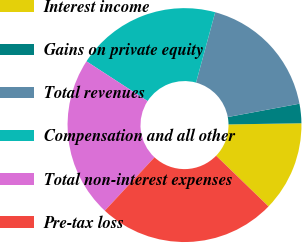Convert chart. <chart><loc_0><loc_0><loc_500><loc_500><pie_chart><fcel>Interest income<fcel>Gains on private equity<fcel>Total revenues<fcel>Compensation and all other<fcel>Total non-interest expenses<fcel>Pre-tax loss<nl><fcel>12.49%<fcel>2.68%<fcel>17.85%<fcel>20.05%<fcel>22.25%<fcel>24.69%<nl></chart> 